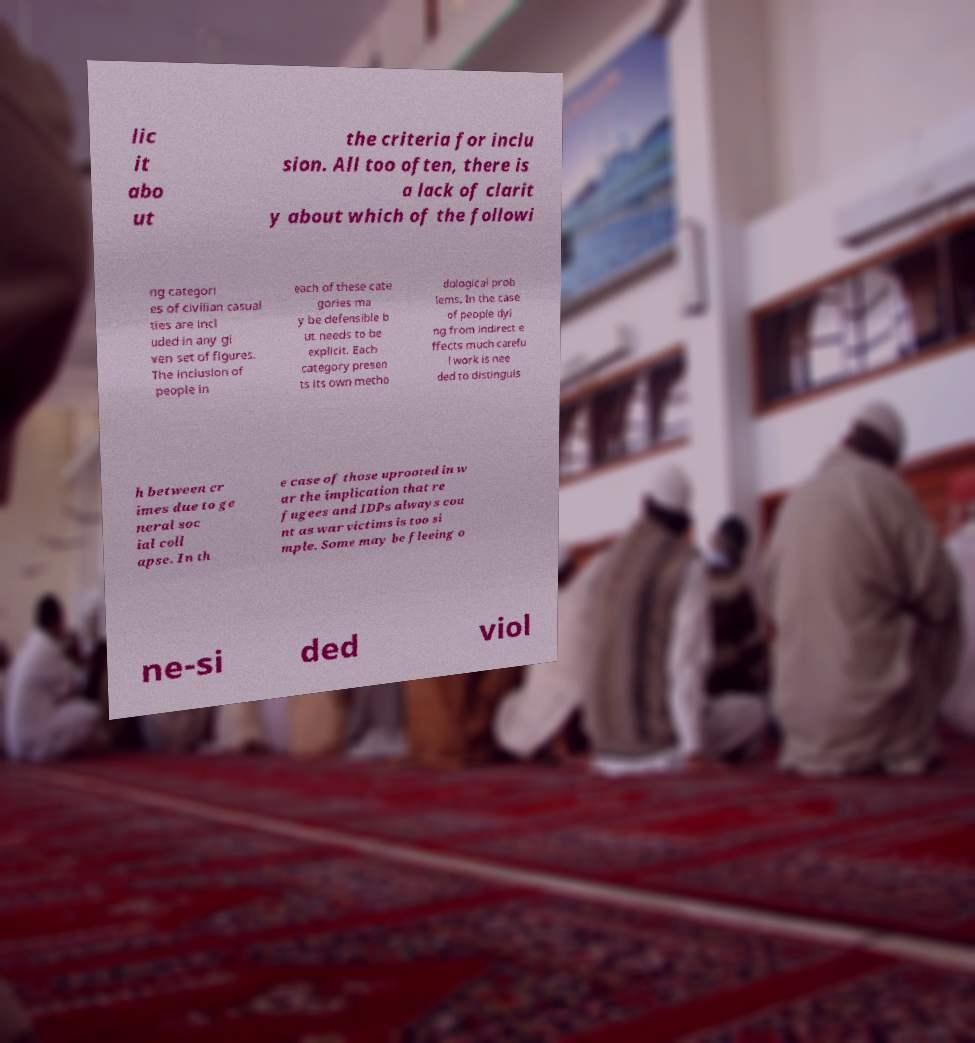What messages or text are displayed in this image? I need them in a readable, typed format. lic it abo ut the criteria for inclu sion. All too often, there is a lack of clarit y about which of the followi ng categori es of civilian casual ties are incl uded in any gi ven set of figures. The inclusion of people in each of these cate gories ma y be defensible b ut needs to be explicit. Each category presen ts its own metho dological prob lems. In the case of people dyi ng from indirect e ffects much carefu l work is nee ded to distinguis h between cr imes due to ge neral soc ial coll apse. In th e case of those uprooted in w ar the implication that re fugees and IDPs always cou nt as war victims is too si mple. Some may be fleeing o ne-si ded viol 